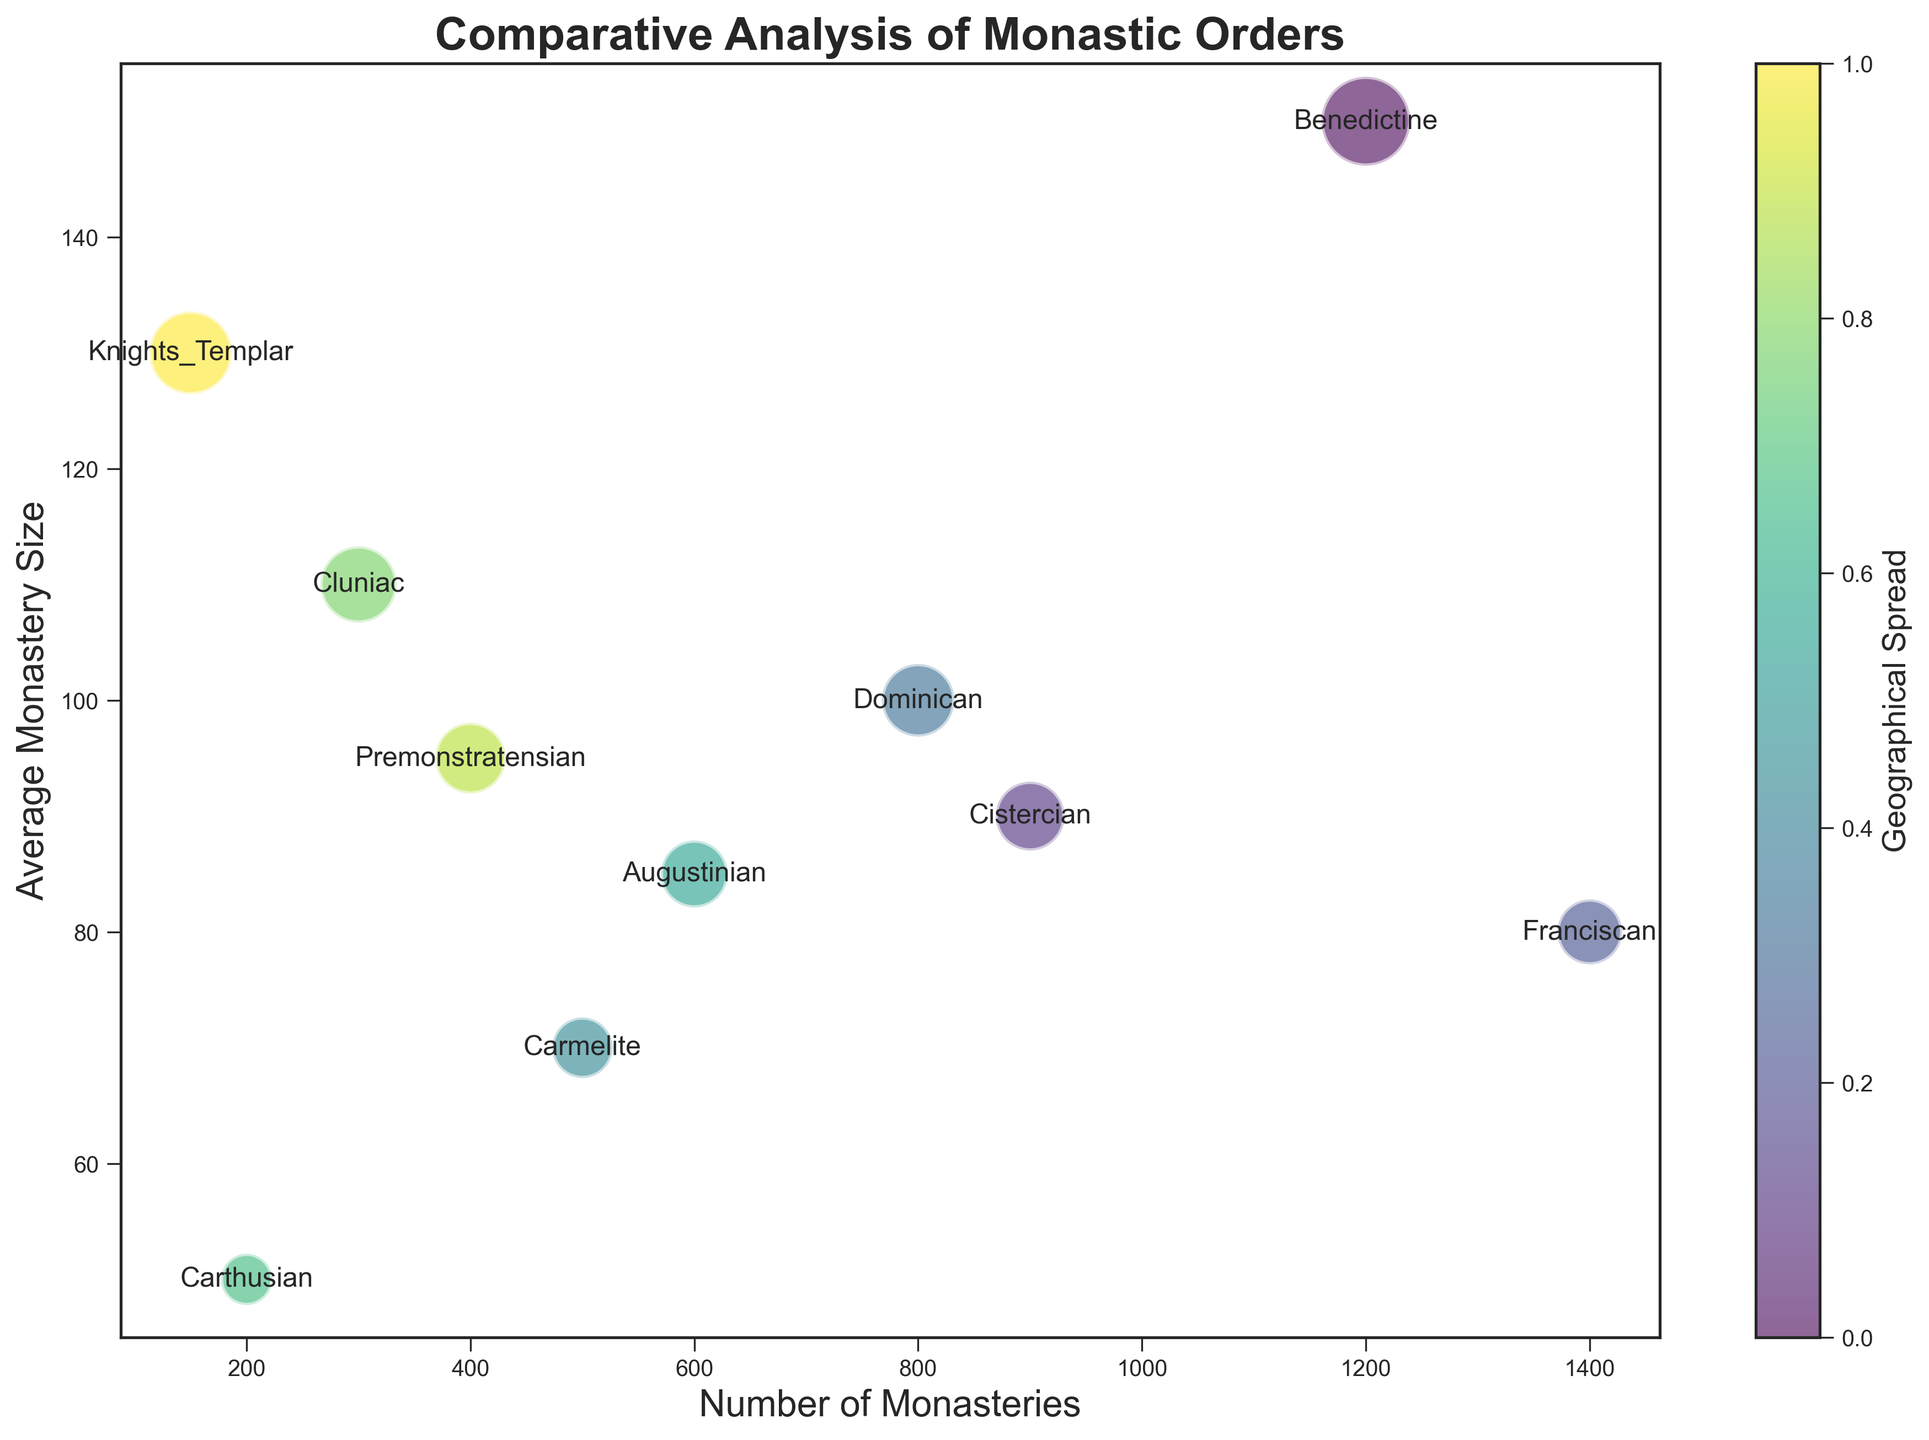Which monastic order has the largest number of monasteries? The order with the highest value on the x-axis (Number of Monasteries) is the Franciscan order, which has 1400 monasteries.
Answer: Franciscan Which monastic order has the smallest average monastery size? The smallest average monastery size appears on the y-axis for the Carthusian order, which has an average size of 50.
Answer: Carthusian Compare the number of monasteries between the Benedictine and Dominican orders. The Benedictine order has 1200 monasteries while the Dominican order has 800. Benedictine has more monasteries.
Answer: Benedictine What is the geographical spread of the Knights Templar order? By noting the annotation on the bubble for the Knights Templar, its geographical spread includes both Europe and the Middle East.
Answer: Europe and Middle East What is the difference in average monastery size between the Cistercian and the Cluniac orders? The average monastery size for the Cistercian order is 90, and for the Cluniac order is 110. The difference is 110 - 90 = 20.
Answer: 20 Which monastic order is represented by the largest bubble in the plot? The largest bubble, indicative of the largest average monastery size, belongs to the Benedictine order with an average size of 150.
Answer: Benedictine What is the combined number of monasteries for the Augustinian and Carmelite orders? The Augustinian order has 600 monasteries and the Carmelite order has 500. The combined number is 600 + 500 = 1100.
Answer: 1100 Which monastic orders have an average monastery size less than 80? The bubbles for the Cistercian, Franciscan, Carmelite, Augustinian, and Carthusian orders are positioned below the 80 mark on the y-axis.
Answer: Cistercian, Franciscan, Carmelite, Carthusian Compare the number of monasteries between the Carthusian and Cluniac orders. The Carthusian order has 200 monasteries while the Cluniac order has 300, so the Cluniac order has more monasteries.
Answer: Cluniac What is the visual indication of geographical spread in the bubble chart? The geographical spread is represented by the color gradient, which varies across the bubbles according to their order and geographical distribution.
Answer: Color gradient 